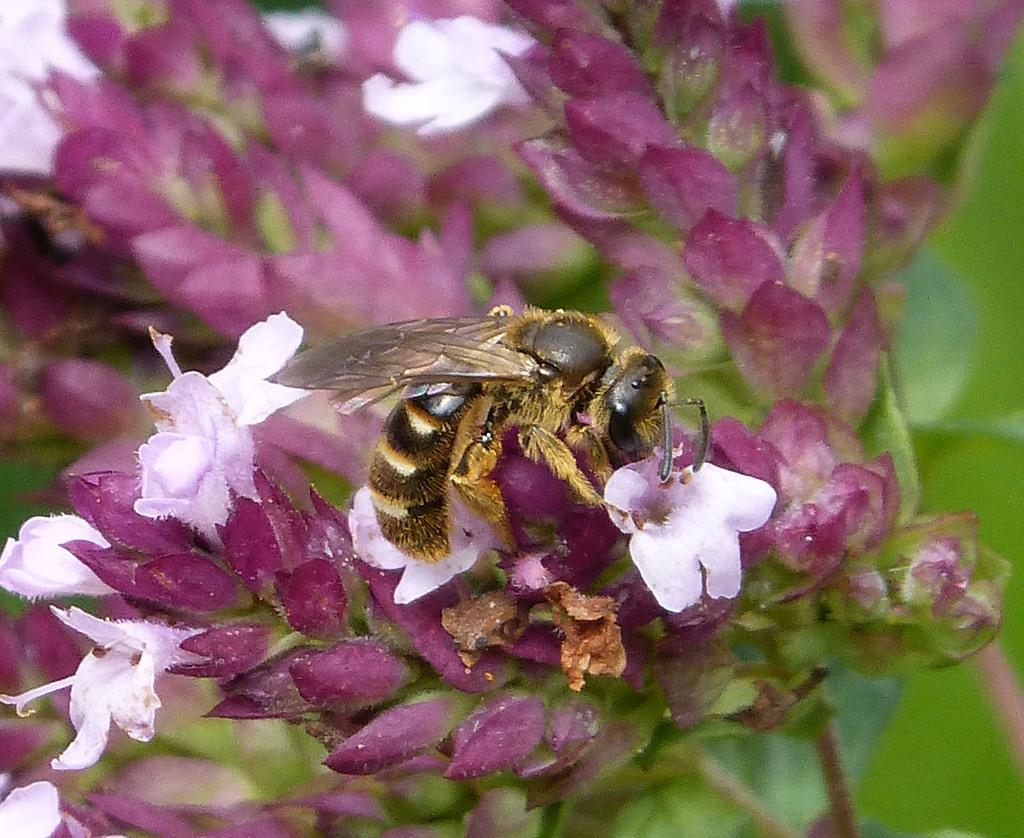What is on the flower in the image? There is an insect on a flower in the image. Can you describe the surroundings of the insect? There are other flowers visible in the image. What type of dust can be seen on the yarn in the image? There is no dust or yarn present in the image; it features an insect on a flower with other flowers visible. 